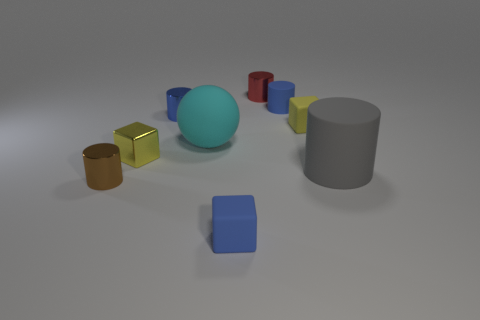The metallic object that is right of the tiny matte object in front of the yellow object on the left side of the large rubber sphere is what color?
Ensure brevity in your answer.  Red. Are there the same number of tiny red objects to the left of the big cyan matte sphere and red things?
Make the answer very short. No. There is a small matte cylinder; is it the same color as the matte cube that is left of the tiny red thing?
Offer a terse response. Yes. Is there a matte cube that is to the right of the metallic cylinder in front of the gray object that is right of the tiny brown metallic cylinder?
Give a very brief answer. Yes. Is the number of small matte cubes left of the red shiny thing less than the number of small cylinders?
Offer a terse response. Yes. How many other objects are there of the same shape as the red metal object?
Keep it short and to the point. 4. What number of objects are either shiny cylinders that are on the left side of the tiny red cylinder or matte objects that are on the left side of the yellow matte thing?
Offer a terse response. 5. What size is the matte thing that is both in front of the yellow matte thing and behind the gray cylinder?
Provide a short and direct response. Large. There is a blue rubber thing that is behind the brown cylinder; is its shape the same as the gray object?
Your answer should be very brief. Yes. What size is the block that is on the left side of the blue matte object that is in front of the matte cylinder that is left of the small yellow rubber object?
Make the answer very short. Small. 